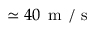<formula> <loc_0><loc_0><loc_500><loc_500>\simeq 4 0 { \, m / s }</formula> 